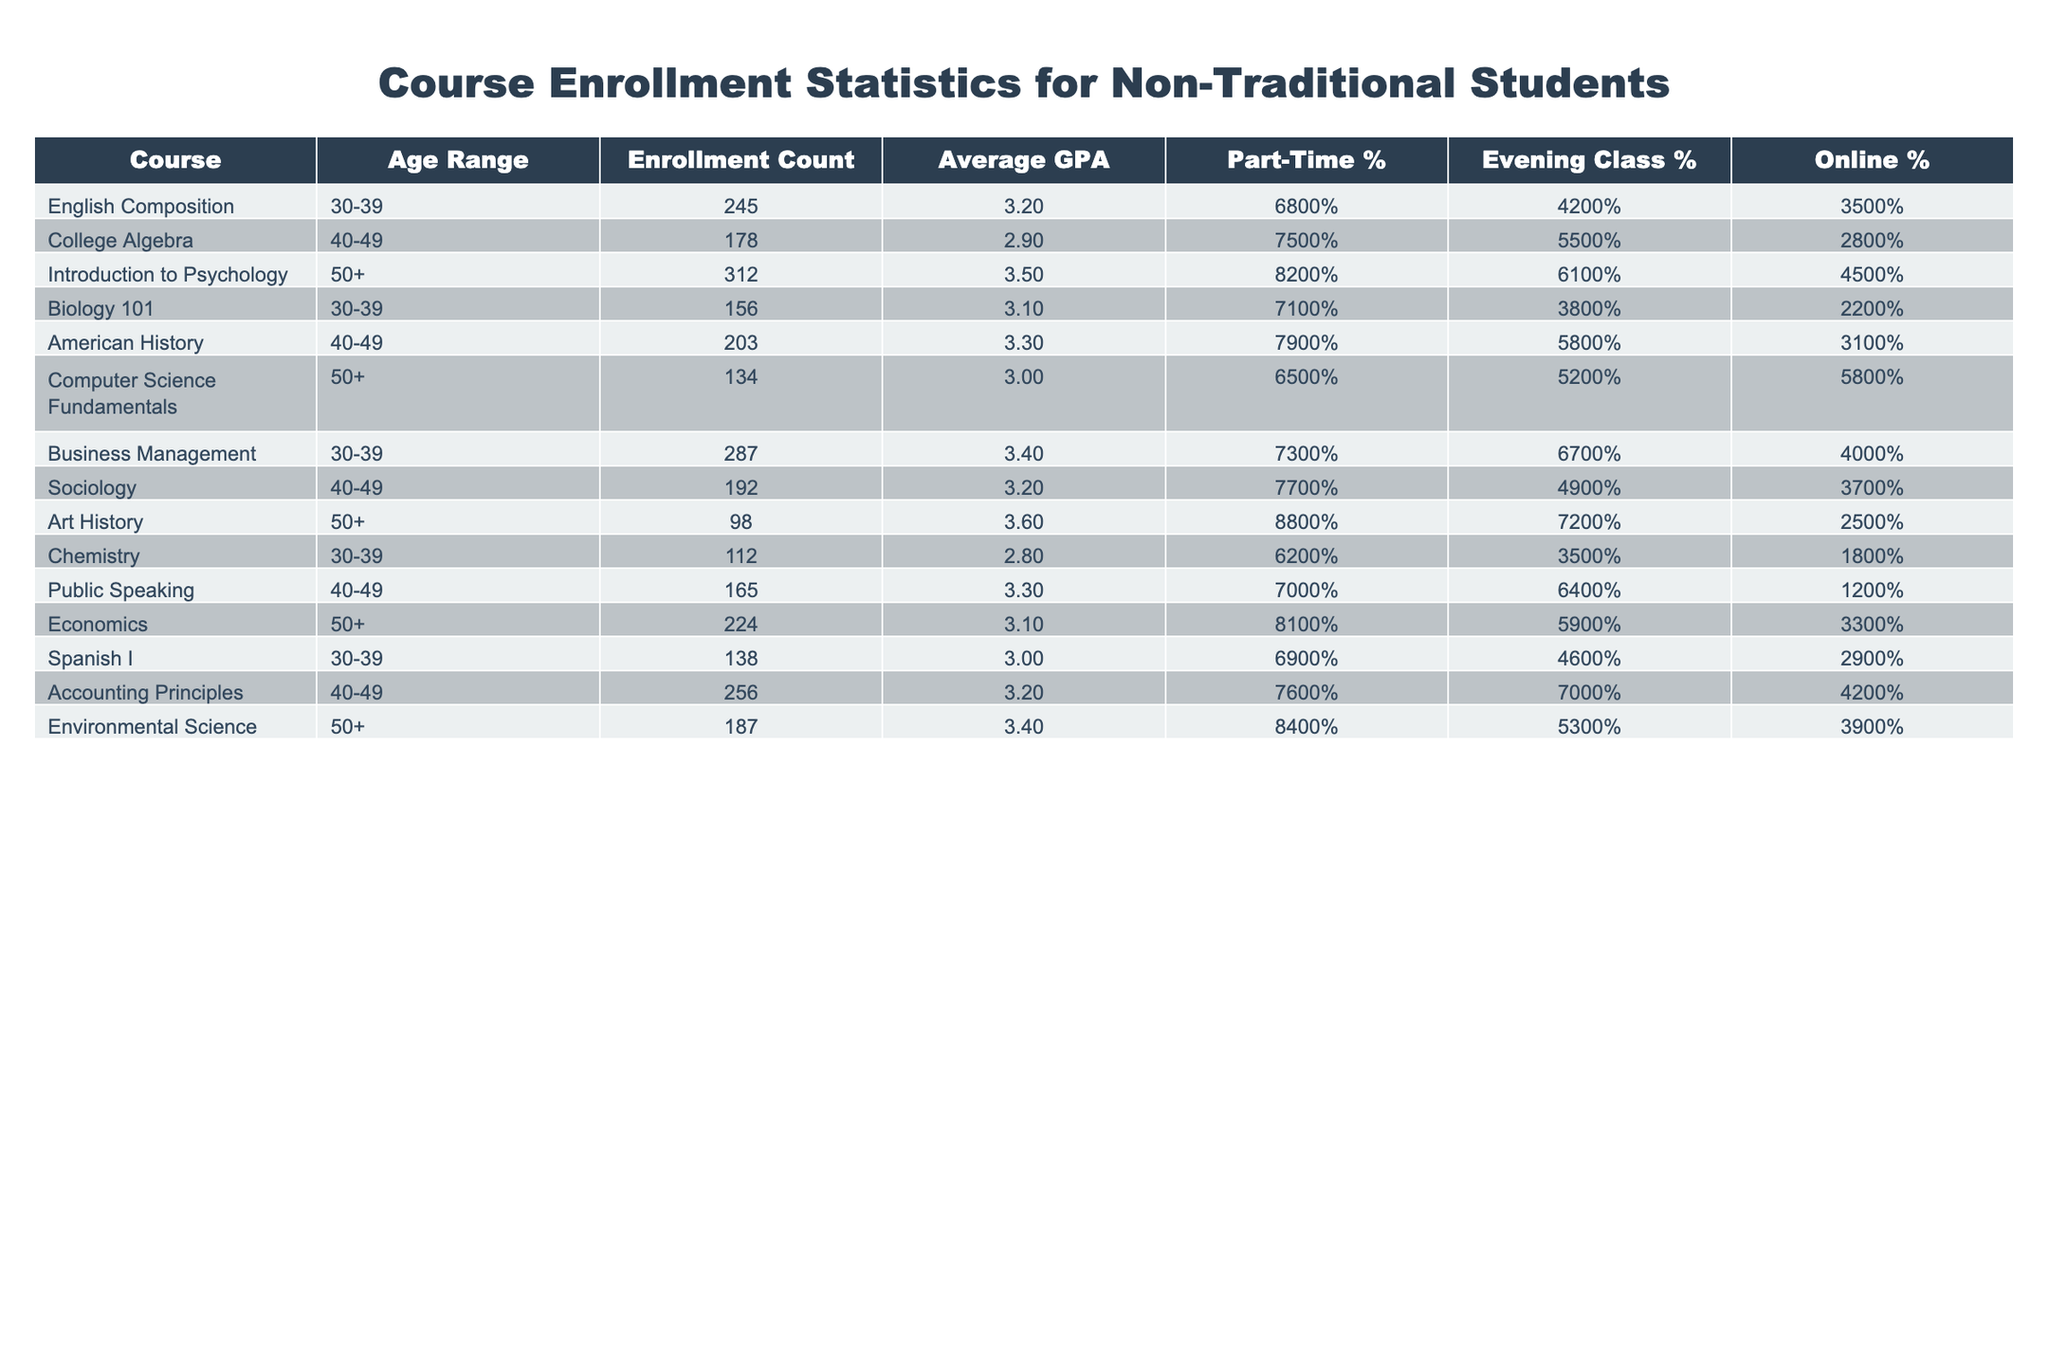What is the enrollment count for the course "Introduction to Psychology"? The table shows the enrollment count specifically for the course "Introduction to Psychology" in the row corresponding to that course. The value is 312.
Answer: 312 What percentage of students enrolled in "College Algebra" take evening classes? Looking at the "College Algebra" row, the evening class percentage is provided. It shows that 55% of students take evening classes.
Answer: 55% Which course has the highest average GPA among students aged 50 and older? Examining the courses listed for the age range 50+, the average GPAs are: Introduction to Psychology (3.5), Computer Science Fundamentals (3.0), Art History (3.6), and Economics (3.1). Art History has the highest GPA of 3.6.
Answer: Art History What is the total enrollment count for courses taken by students aged 30-39? Adding the enrollment counts for the courses available in the age range 30-39: English Composition (245), Biology 101 (156), Business Management (287), Chemistry (112), and Spanish I (138), we get 245 + 156 + 287 + 112 + 138 = 938.
Answer: 938 Is the average GPA for "Environmental Science" higher than that of "Computer Science Fundamentals"? Looking at the rows for Environmental Science and Computer Science Fundamentals, the average GPAs are 3.4 and 3.0, respectively. Since 3.4 is greater than 3.0, the statement is true.
Answer: Yes What is the difference in enrollment count between the courses "Accounting Principles" and "Business Management"? The enrollment count for Accounting Principles is 256 and for Business Management is 287. The difference can be calculated as 287 - 256 = 31.
Answer: 31 How many courses have a part-time enrollment percentage greater than 75%? Scanning the part-time percentage column, the courses with percentages greater than 75% are College Algebra (75%), Introduction to Psychology (82%), American History (79%), Economics (81%), and Accounting Principles (76%). This gives us a total of 5 courses.
Answer: 5 What is the average enrollment count across all courses listed? To find the average, we need to sum the enrollment counts: 245 + 178 + 312 + 156 + 203 + 134 + 287 + 192 + 98 + 165 + 224 + 138 + 256 + 187 = 2,434, and then divide by the number of courses, which is 14. Thus, the average is 2,434 / 14 ≈ 173.86.
Answer: 173.86 Are there more courses with evening classes than online classes? Evaluating the evening class percentages versus the online percentages for each course shows that there are 6 courses with evening class percentages above 50% and 5 courses with online percentages above 50%. Hence, there are more courses with evening classes.
Answer: Yes Which age range has the lowest average GPA and what is that GPA? To find the lowest average GPA, we will compare the average GPAs in the table for each age range: 30-39 (3.2), 40-49 (3.2), and 50+ (3.5), finding the lowest is 2.8 from Chemistry, corresponding to age range 30-39. Hence the GPA is 2.8.
Answer: 2.8 